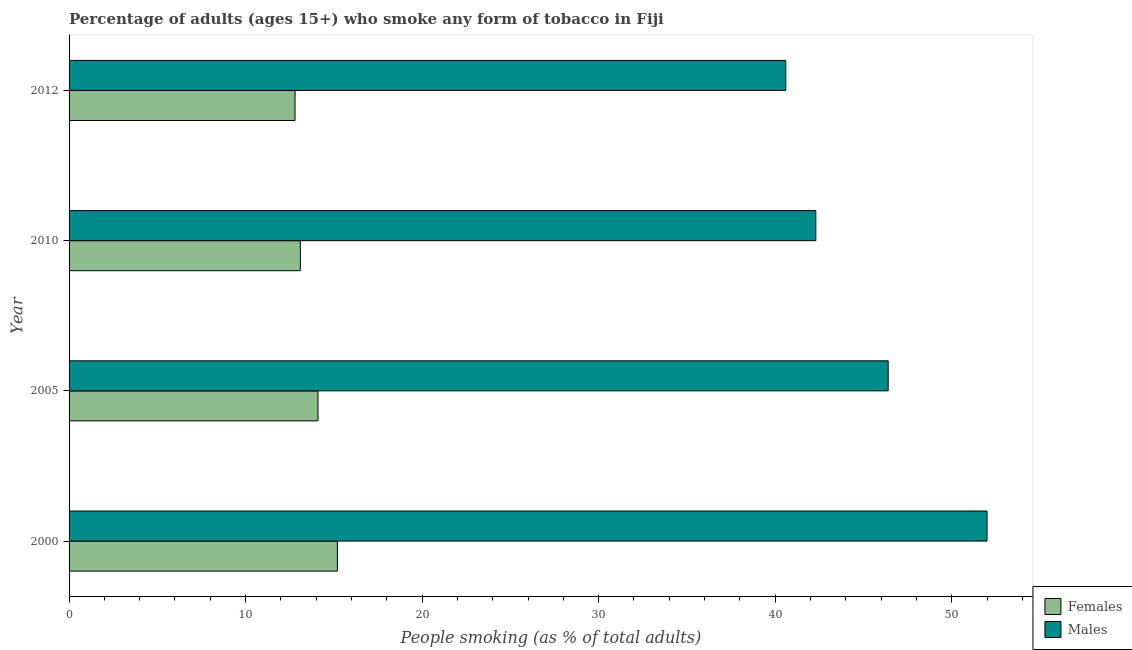How many different coloured bars are there?
Keep it short and to the point. 2. Are the number of bars per tick equal to the number of legend labels?
Offer a terse response. Yes. Are the number of bars on each tick of the Y-axis equal?
Offer a terse response. Yes. What is the label of the 2nd group of bars from the top?
Your answer should be compact. 2010. Across all years, what is the minimum percentage of females who smoke?
Make the answer very short. 12.8. In which year was the percentage of males who smoke maximum?
Your response must be concise. 2000. In which year was the percentage of males who smoke minimum?
Make the answer very short. 2012. What is the total percentage of females who smoke in the graph?
Your response must be concise. 55.2. What is the difference between the percentage of females who smoke in 2000 and the percentage of males who smoke in 2005?
Your answer should be very brief. -31.2. What is the average percentage of males who smoke per year?
Your answer should be very brief. 45.33. In the year 2005, what is the difference between the percentage of males who smoke and percentage of females who smoke?
Your response must be concise. 32.3. In how many years, is the percentage of males who smoke greater than 6 %?
Offer a very short reply. 4. What is the ratio of the percentage of females who smoke in 2005 to that in 2012?
Ensure brevity in your answer.  1.1. Is the difference between the percentage of females who smoke in 2010 and 2012 greater than the difference between the percentage of males who smoke in 2010 and 2012?
Offer a very short reply. No. What is the difference between the highest and the lowest percentage of males who smoke?
Provide a succinct answer. 11.4. What does the 1st bar from the top in 2005 represents?
Your answer should be very brief. Males. What does the 2nd bar from the bottom in 2005 represents?
Offer a very short reply. Males. How many bars are there?
Offer a terse response. 8. Are all the bars in the graph horizontal?
Offer a very short reply. Yes. What is the difference between two consecutive major ticks on the X-axis?
Offer a terse response. 10. Does the graph contain any zero values?
Your response must be concise. No. Where does the legend appear in the graph?
Provide a short and direct response. Bottom right. What is the title of the graph?
Ensure brevity in your answer.  Percentage of adults (ages 15+) who smoke any form of tobacco in Fiji. Does "Girls" appear as one of the legend labels in the graph?
Make the answer very short. No. What is the label or title of the X-axis?
Ensure brevity in your answer.  People smoking (as % of total adults). What is the label or title of the Y-axis?
Give a very brief answer. Year. What is the People smoking (as % of total adults) of Females in 2000?
Give a very brief answer. 15.2. What is the People smoking (as % of total adults) in Males in 2005?
Your response must be concise. 46.4. What is the People smoking (as % of total adults) in Females in 2010?
Provide a short and direct response. 13.1. What is the People smoking (as % of total adults) in Males in 2010?
Your answer should be very brief. 42.3. What is the People smoking (as % of total adults) of Males in 2012?
Offer a very short reply. 40.6. Across all years, what is the maximum People smoking (as % of total adults) in Males?
Provide a succinct answer. 52. Across all years, what is the minimum People smoking (as % of total adults) of Females?
Your response must be concise. 12.8. Across all years, what is the minimum People smoking (as % of total adults) of Males?
Offer a terse response. 40.6. What is the total People smoking (as % of total adults) of Females in the graph?
Offer a terse response. 55.2. What is the total People smoking (as % of total adults) of Males in the graph?
Your answer should be very brief. 181.3. What is the difference between the People smoking (as % of total adults) of Males in 2000 and that in 2005?
Your answer should be compact. 5.6. What is the difference between the People smoking (as % of total adults) of Females in 2000 and that in 2010?
Give a very brief answer. 2.1. What is the difference between the People smoking (as % of total adults) in Females in 2000 and that in 2012?
Provide a succinct answer. 2.4. What is the difference between the People smoking (as % of total adults) of Females in 2005 and that in 2010?
Give a very brief answer. 1. What is the difference between the People smoking (as % of total adults) in Females in 2005 and that in 2012?
Provide a short and direct response. 1.3. What is the difference between the People smoking (as % of total adults) in Males in 2005 and that in 2012?
Your answer should be compact. 5.8. What is the difference between the People smoking (as % of total adults) in Females in 2010 and that in 2012?
Provide a succinct answer. 0.3. What is the difference between the People smoking (as % of total adults) in Males in 2010 and that in 2012?
Keep it short and to the point. 1.7. What is the difference between the People smoking (as % of total adults) in Females in 2000 and the People smoking (as % of total adults) in Males in 2005?
Offer a very short reply. -31.2. What is the difference between the People smoking (as % of total adults) in Females in 2000 and the People smoking (as % of total adults) in Males in 2010?
Your response must be concise. -27.1. What is the difference between the People smoking (as % of total adults) of Females in 2000 and the People smoking (as % of total adults) of Males in 2012?
Your answer should be compact. -25.4. What is the difference between the People smoking (as % of total adults) of Females in 2005 and the People smoking (as % of total adults) of Males in 2010?
Your answer should be compact. -28.2. What is the difference between the People smoking (as % of total adults) in Females in 2005 and the People smoking (as % of total adults) in Males in 2012?
Offer a very short reply. -26.5. What is the difference between the People smoking (as % of total adults) of Females in 2010 and the People smoking (as % of total adults) of Males in 2012?
Give a very brief answer. -27.5. What is the average People smoking (as % of total adults) of Females per year?
Keep it short and to the point. 13.8. What is the average People smoking (as % of total adults) in Males per year?
Your answer should be very brief. 45.33. In the year 2000, what is the difference between the People smoking (as % of total adults) in Females and People smoking (as % of total adults) in Males?
Your answer should be compact. -36.8. In the year 2005, what is the difference between the People smoking (as % of total adults) in Females and People smoking (as % of total adults) in Males?
Provide a short and direct response. -32.3. In the year 2010, what is the difference between the People smoking (as % of total adults) in Females and People smoking (as % of total adults) in Males?
Keep it short and to the point. -29.2. In the year 2012, what is the difference between the People smoking (as % of total adults) in Females and People smoking (as % of total adults) in Males?
Offer a terse response. -27.8. What is the ratio of the People smoking (as % of total adults) of Females in 2000 to that in 2005?
Your response must be concise. 1.08. What is the ratio of the People smoking (as % of total adults) of Males in 2000 to that in 2005?
Make the answer very short. 1.12. What is the ratio of the People smoking (as % of total adults) in Females in 2000 to that in 2010?
Ensure brevity in your answer.  1.16. What is the ratio of the People smoking (as % of total adults) in Males in 2000 to that in 2010?
Offer a very short reply. 1.23. What is the ratio of the People smoking (as % of total adults) of Females in 2000 to that in 2012?
Your answer should be compact. 1.19. What is the ratio of the People smoking (as % of total adults) in Males in 2000 to that in 2012?
Your answer should be very brief. 1.28. What is the ratio of the People smoking (as % of total adults) of Females in 2005 to that in 2010?
Provide a short and direct response. 1.08. What is the ratio of the People smoking (as % of total adults) of Males in 2005 to that in 2010?
Offer a terse response. 1.1. What is the ratio of the People smoking (as % of total adults) of Females in 2005 to that in 2012?
Your answer should be compact. 1.1. What is the ratio of the People smoking (as % of total adults) of Females in 2010 to that in 2012?
Your answer should be very brief. 1.02. What is the ratio of the People smoking (as % of total adults) of Males in 2010 to that in 2012?
Provide a succinct answer. 1.04. What is the difference between the highest and the lowest People smoking (as % of total adults) of Males?
Offer a very short reply. 11.4. 